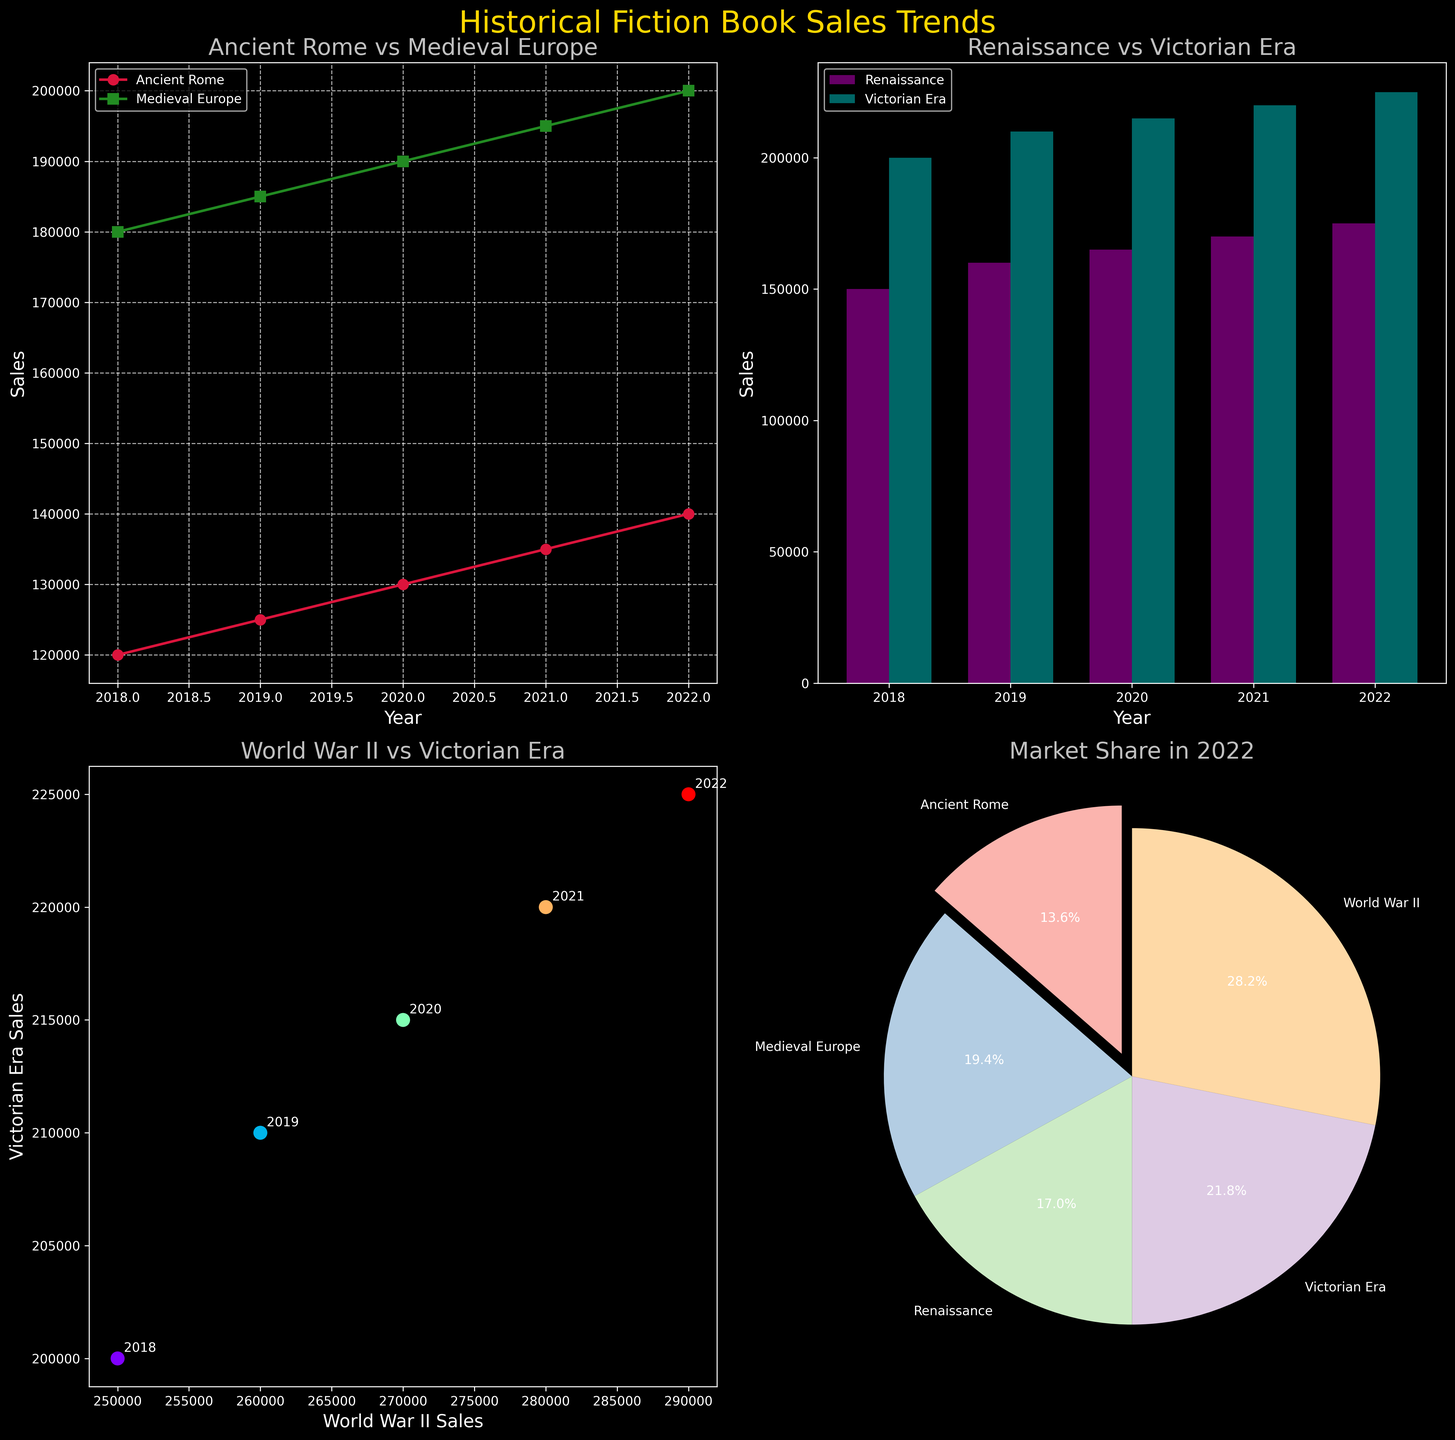What's the latest year's book sales for Ancient Rome and Medieval Europe? The line plot for 'Ancient Rome vs Medieval Europe' shows the sales trends over the years. For the latest year (2022), the sales for Ancient Rome are at the highest point on that line, and the sales for Medieval Europe are similarly at the highest point for its respective line. According to the y-axis values, these are 140,000 and 200,000 respectively.
Answer: 140,000 and 200,000 Which historical period saw the greatest increase in sales from 2018 to 2022? To find which historical period saw the greatest increase, calculate the difference in sales from 2018 to 2022 for each period. The differences are:
- Ancient Rome: 140,000 - 120,000 = 20,000
- Medieval Europe: 200,000 - 180,000 = 20,000
- Renaissance: 175,000 - 150,000 = 25,000
- Victorian Era: 225,000 - 200,000 = 25,000
- World War II: 290,000 - 250,000 = 40,000
World War II has the greatest increase.
Answer: World War II What is the trend seen in the scatter plot between World War II and Victorian Era sales? The scatter plot shows the relationship between World War II and Victorian Era sales over various years. The plot shows an upward trend, as the points generally increase together year by year, indicating a positive correlation between the two sales trends.
Answer: Positive correlation Which historical period had the highest market share in 2022 based on the pie chart? The pie chart represents the market shares of different historical periods in 2022. Each sector of the pie represents the sales for that period as a percentage. World War II, indicated by the largest sector of the pie, has the highest market share.
Answer: World War II How do the sales of Renaissance compare with Victorian Era sales in the bar plot? In the bar plot, each year has paired bars for Renaissance and Victorian Era. Comparing the heights of the bars for each year from 2018 to 2022 shows that Victorian Era consistently has higher sales each year.
Answer: Victorian Era What's the difference in sales between Ancient Rome and Medieval Europe in 2020? By referring to the line plot for 'Ancient Rome vs Medieval Europe' in 2020, Ancient Rome has sales of 130,000 and Medieval Europe has sales of 190,000. The difference is 190,000 - 130,000.
Answer: 60,000 In which year did the sales of Victorian Era and World War II first reach over 200,000 on the bar plot? Looking closely at the bar chart and tracing the values above 200,000 for both Victorian Era and World War II, both reached 200,000 in 2018 and 2019 respectively. However, since the first reach exclusively for each, World War II reached 200,000 in 2018 while Victorian Era in 2019.
Answer: 2019 What does the annotation in the scatter plot represent? The annotations in the scatter plot represent the year corresponding to each data point, helping to identify which sales values correspond to which year for World War II and Victorian Era.
Answer: Year 